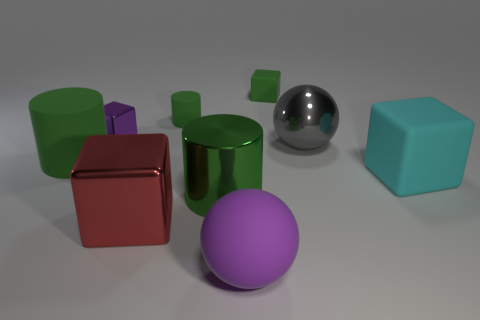Subtract all gray blocks. Subtract all brown balls. How many blocks are left? 4 Subtract all balls. How many objects are left? 7 Add 9 big green shiny things. How many big green shiny things exist? 10 Subtract 0 brown blocks. How many objects are left? 9 Subtract all tiny gray rubber cylinders. Subtract all small green rubber things. How many objects are left? 7 Add 1 big red shiny cubes. How many big red shiny cubes are left? 2 